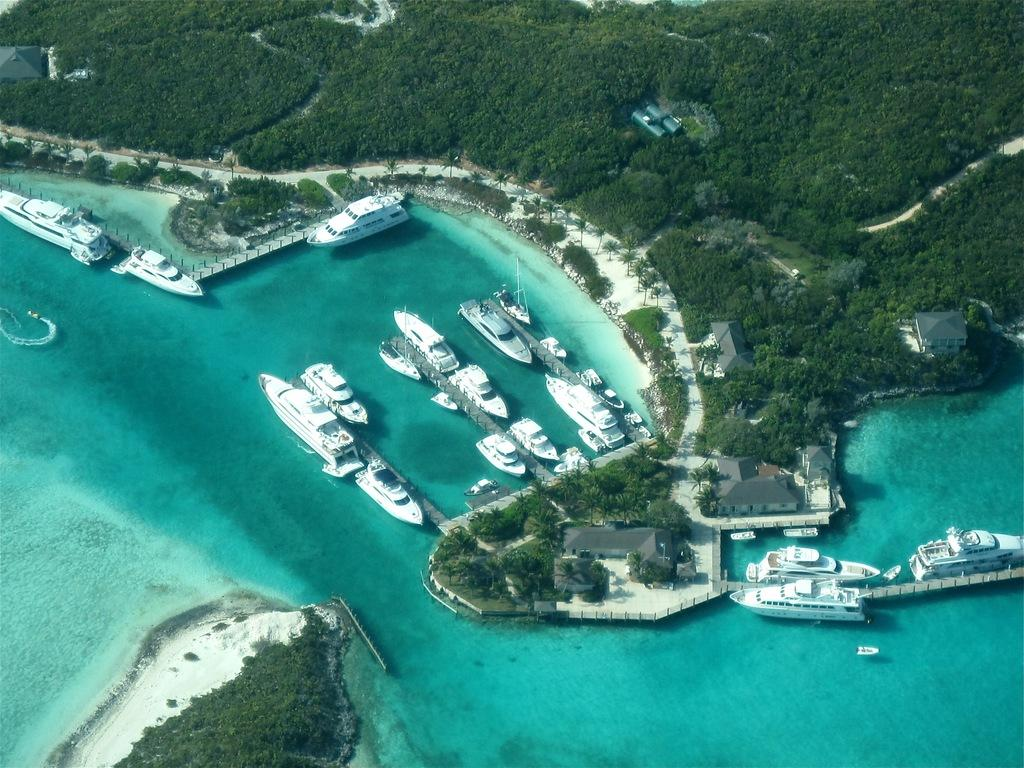What is the primary element visible in the image? There is water in the image. What types of vehicles can be seen in the image? There are ships in the image. What structures are present in the image? There are buildings in the image. What type of vegetation is visible in the image? There are trees in the image. Where is the alley located in the image? There is no alley present in the image. Can you identify any spies in the image? There are no spies present in the image. 